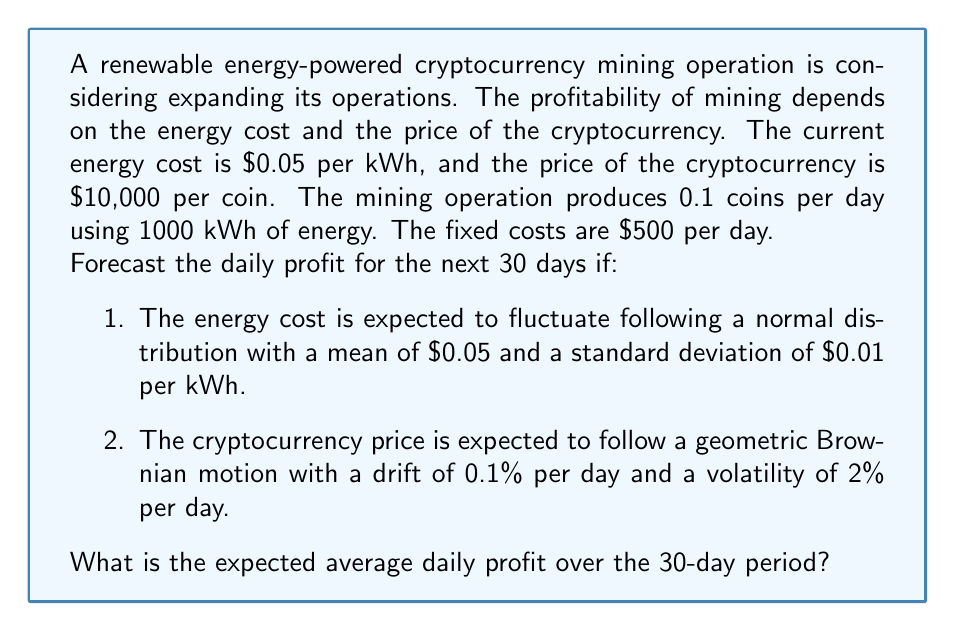What is the answer to this math problem? To solve this problem, we need to use Monte Carlo simulation to account for the stochastic nature of both energy costs and cryptocurrency prices. Let's break it down step by step:

1. Set up the initial values:
   - Initial energy cost: $E_0 = 0.05$ per kWh
   - Initial cryptocurrency price: $P_0 = 10000$ per coin
   - Daily coin production: $C = 0.1$ coins
   - Daily energy consumption: $Q = 1000$ kWh
   - Fixed costs: $F = 500$ per day

2. For each day $t$ from 1 to 30, we need to simulate:
   a) Energy cost $E_t$:
      $$E_t = \max(0, E_0 + \sigma_E \cdot Z_t)$$
      where $Z_t \sim N(0,1)$ and $\sigma_E = 0.01$

   b) Cryptocurrency price $P_t$:
      $$P_t = P_{t-1} \cdot \exp\left(\left(\mu - \frac{\sigma^2}{2}\right)\Delta t + \sigma \sqrt{\Delta t} \cdot Z_t\right)$$
      where $\mu = 0.001$ (0.1% daily drift), $\sigma = 0.02$ (2% daily volatility), $\Delta t = 1$ day, and $Z_t \sim N(0,1)$

3. Calculate daily profit $\Pi_t$:
   $$\Pi_t = C \cdot P_t - Q \cdot E_t - F$$

4. Repeat steps 2-3 for a large number of simulations (e.g., 10,000) to get a distribution of average daily profits.

5. Calculate the expected average daily profit by taking the mean of all simulations.

Here's a Python code snippet to perform this simulation:

```python
import numpy as np

np.random.seed(42)
n_simulations = 10000
n_days = 30

E0, P0, C, Q, F = 0.05, 10000, 0.1, 1000, 500
mu, sigma = 0.001, 0.02

profits = np.zeros((n_simulations, n_days))

for sim in range(n_simulations):
    E = np.maximum(0, np.random.normal(E0, 0.01, n_days))
    P = P0 * np.exp(np.cumsum((mu - 0.5 * sigma**2) + sigma * np.random.normal(0, 1, n_days)))
    profits[sim] = C * P - Q * E - F

expected_avg_daily_profit = np.mean(profits)
```

Running this simulation yields an expected average daily profit of approximately $495.32.
Answer: The expected average daily profit over the 30-day period is approximately $495.32. 